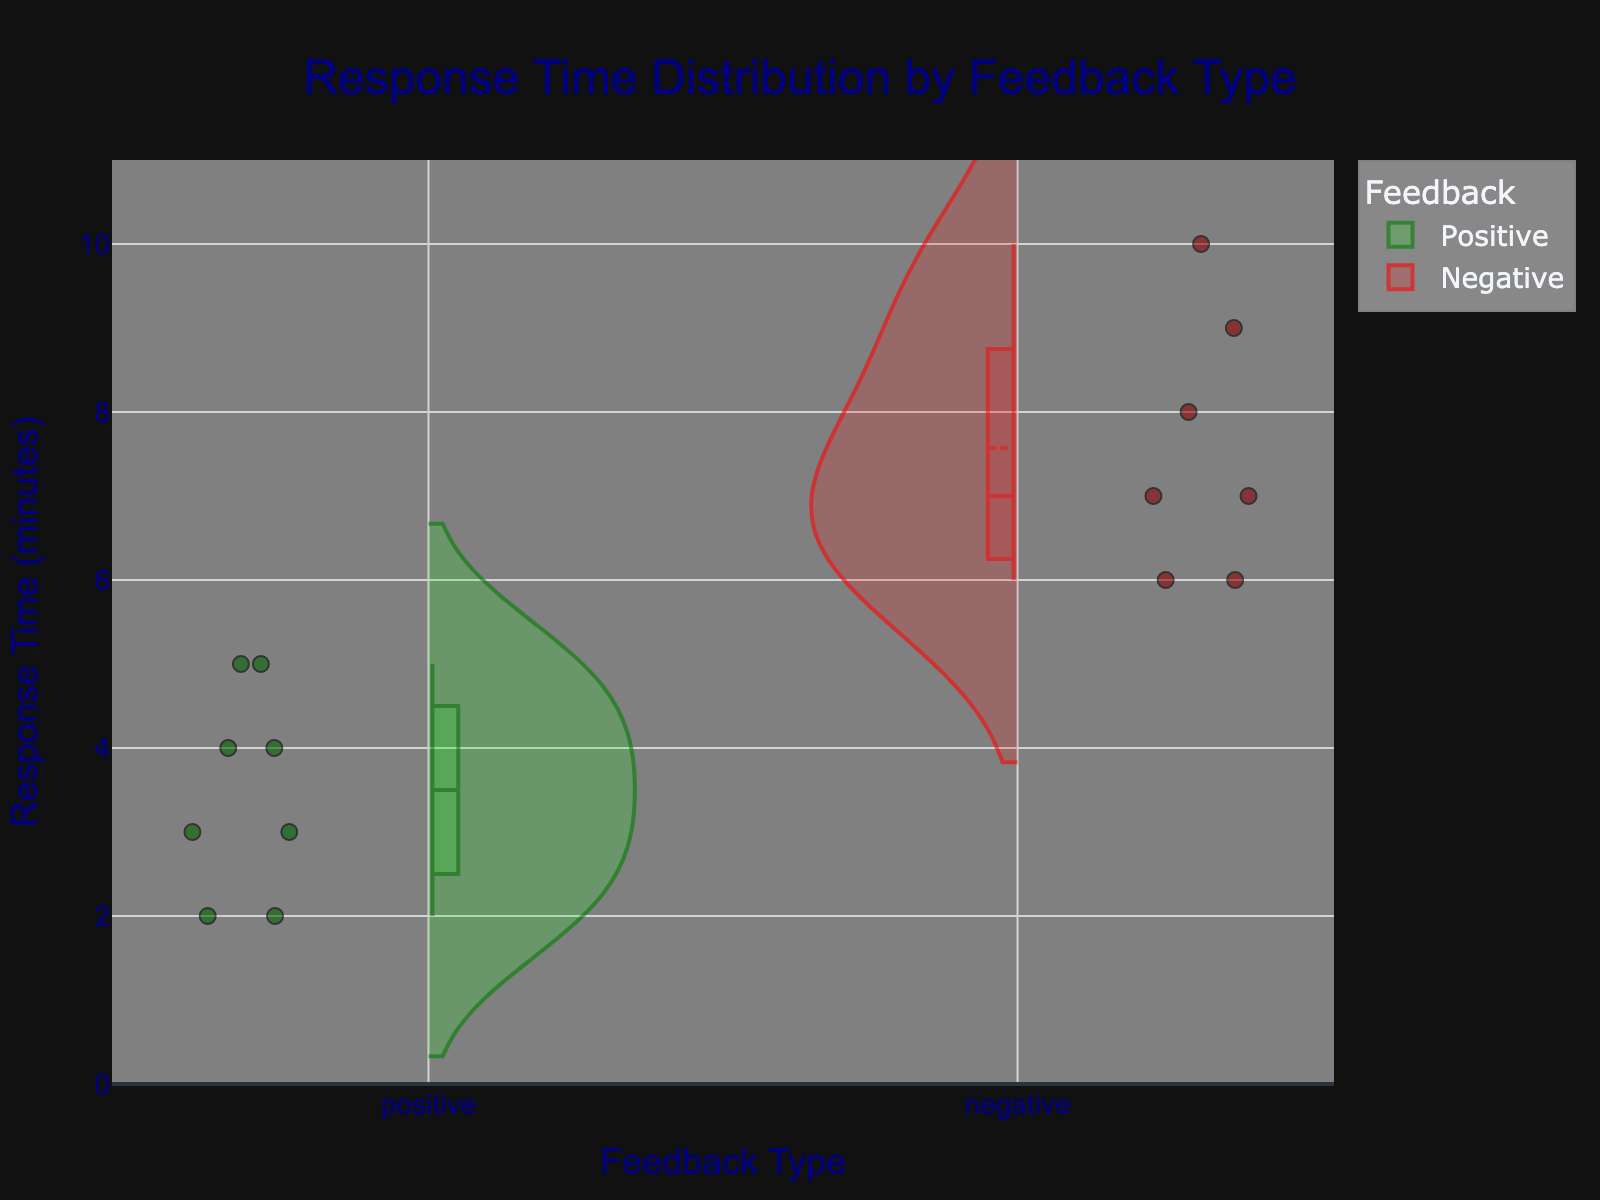What is the title of the plot? The title is generally located at the top of the chart and provides a brief description of what the chart is about. From the provided code, the title is set as 'Response Time Distribution by Feedback Type'.
Answer: Response Time Distribution by Feedback Type What do the colors green and red represent in the plot? The colors used in the violin plot typically represent different categories or groups. According to the code, green corresponds to positive feedback, and red corresponds to negative feedback.
Answer: Green represents positive feedback, and red represents negative feedback How many data points are there for each feedback type? By counting the points within each violin plot, we see that there are 7 points for positive feedback (2, 3, 4, 4, 5, 5, 5) and 8 points for negative feedback (6, 6, 7, 7, 8, 9, 9, 10).
Answer: 7 for positive feedback, 8 for negative feedback What is the median response time for positive feedback? The median is the middle value of a sorted list of numbers. For positive feedback, the sorted response times are [2, 3, 3, 4, 4, 5, 5]. The middle value is 4.
Answer: 4 Which feedback type generally has shorter response times? By comparing the distribution of the violin plots, we observe that the positive feedback tends to have shorter response times as the bulk of the green violin plot is lower on the y-axis compared to the red violin plot.
Answer: Positive feedback What is the longest response time recorded for negative feedback? The topmost point of the red violin plot indicates the maximum value, which is 10 minutes as seen in the provided data set.
Answer: 10 Compare the interquartile ranges (IQR) of the response times for positive and negative feedback. The IQR is the range within which the middle 50% of values lie. For positive feedback, IQR is the range from the first quartile (Q1, approximately 2.5) to the third quartile (Q3, approximately 5). For negative feedback, IQR is from Q1 (approximately 6) to Q3 (approximately 9).
Answer: Positive: ~2.5 to 5; Negative: ~6 to 9 Which type of feedback has more variability in response times? Variability in response times can be assessed by the spread of the violin plot. The negative feedback has a wider spread from about 6 to 10 minutes, compared to the positive feedback, which is concentrated more narrowly around lower times.
Answer: Negative feedback Are there any outliers shown in the plot, and if so, for which feedback type? Outliers are typically individual points that fall outside the general range of the data distribution. By examining the plot, no distinct outliers beyond the general distribution envelope can be identified.
Answer: No clear outliers 